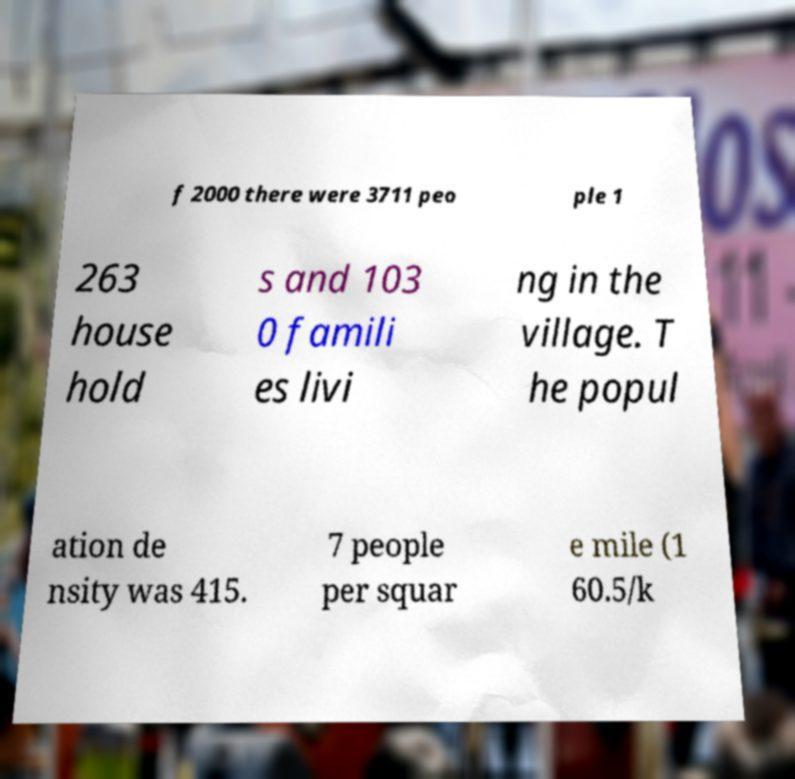I need the written content from this picture converted into text. Can you do that? f 2000 there were 3711 peo ple 1 263 house hold s and 103 0 famili es livi ng in the village. T he popul ation de nsity was 415. 7 people per squar e mile (1 60.5/k 